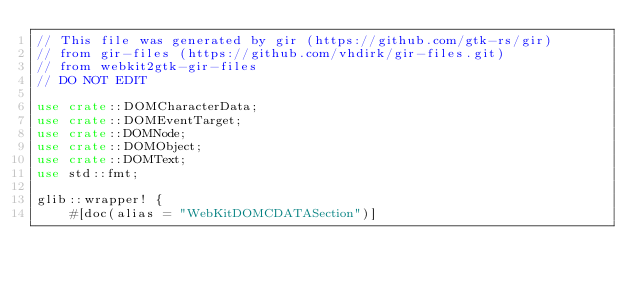Convert code to text. <code><loc_0><loc_0><loc_500><loc_500><_Rust_>// This file was generated by gir (https://github.com/gtk-rs/gir)
// from gir-files (https://github.com/vhdirk/gir-files.git)
// from webkit2gtk-gir-files
// DO NOT EDIT

use crate::DOMCharacterData;
use crate::DOMEventTarget;
use crate::DOMNode;
use crate::DOMObject;
use crate::DOMText;
use std::fmt;

glib::wrapper! {
    #[doc(alias = "WebKitDOMCDATASection")]</code> 